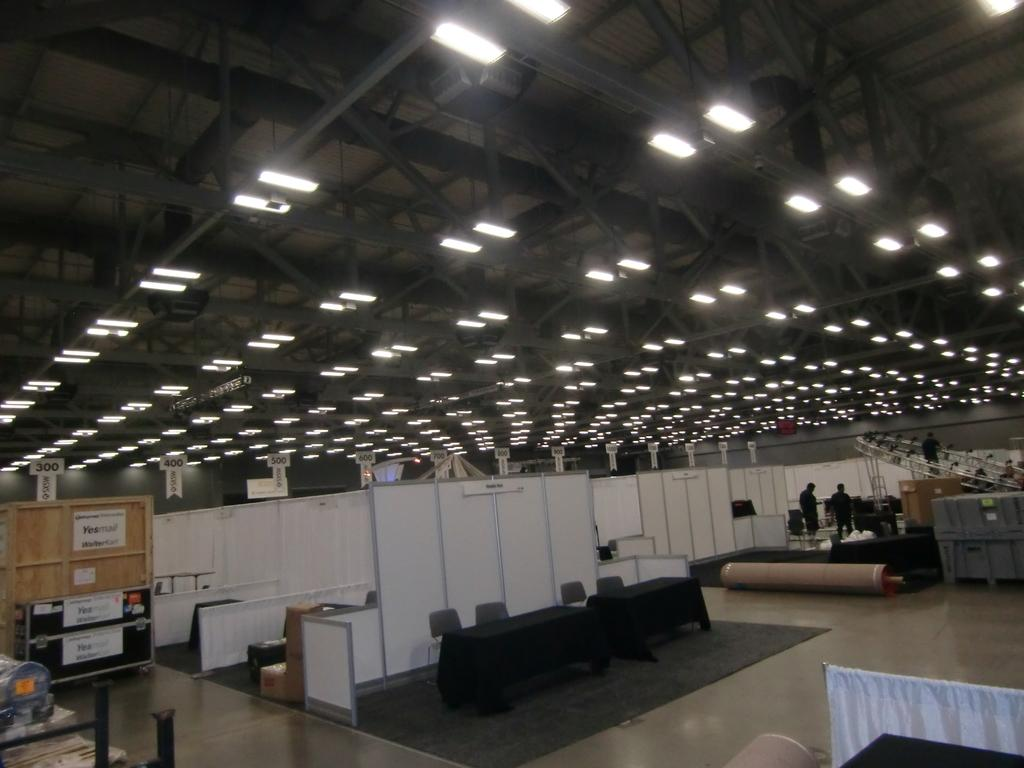How many people are in the image? There are two persons standing in the image. What is in front of the persons? There are four chairs in front of the persons. What is between the chairs? There is a table in front of the chairs. What can be seen at the back of the image? There are lights visible at the back of the image. What is on the left side of the image? There is a brown-colored board on the left side of the image. How many books are on the table in the image? There is no mention of books in the image, so we cannot determine the number of books on the table. Is there snow visible in the image? There is no mention of snow in the image, so we cannot determine if snow is visible. 